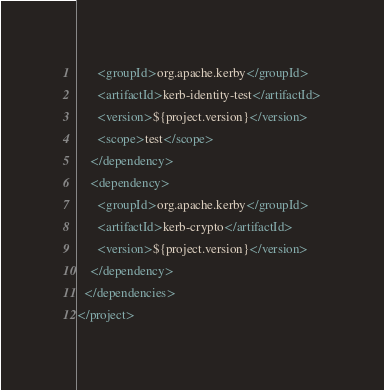<code> <loc_0><loc_0><loc_500><loc_500><_XML_>      <groupId>org.apache.kerby</groupId>
      <artifactId>kerb-identity-test</artifactId>
      <version>${project.version}</version>
      <scope>test</scope>
    </dependency>
    <dependency>
      <groupId>org.apache.kerby</groupId>
      <artifactId>kerb-crypto</artifactId>
      <version>${project.version}</version>
    </dependency>
  </dependencies>
</project>
</code> 